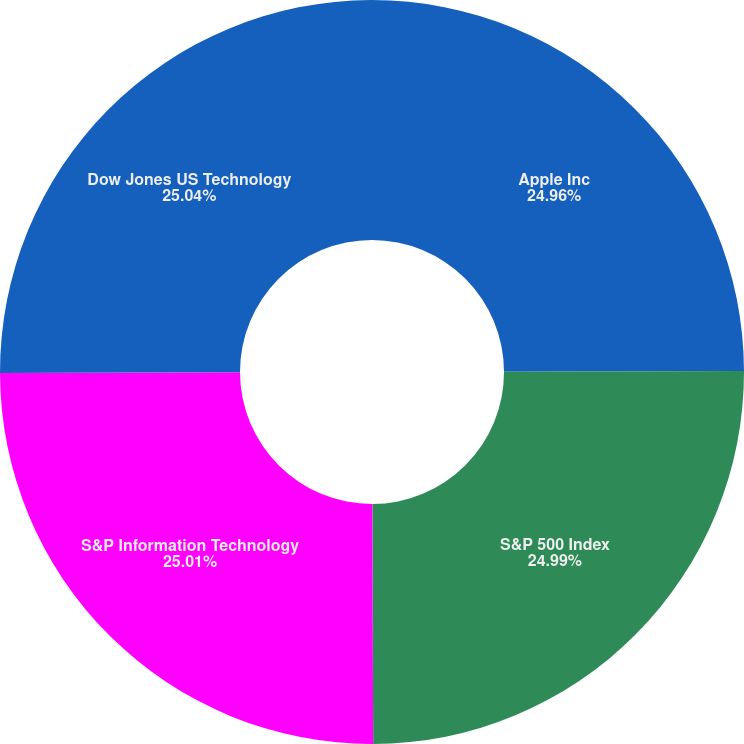Convert chart. <chart><loc_0><loc_0><loc_500><loc_500><pie_chart><fcel>Apple Inc<fcel>S&P 500 Index<fcel>S&P Information Technology<fcel>Dow Jones US Technology<nl><fcel>24.96%<fcel>24.99%<fcel>25.01%<fcel>25.04%<nl></chart> 